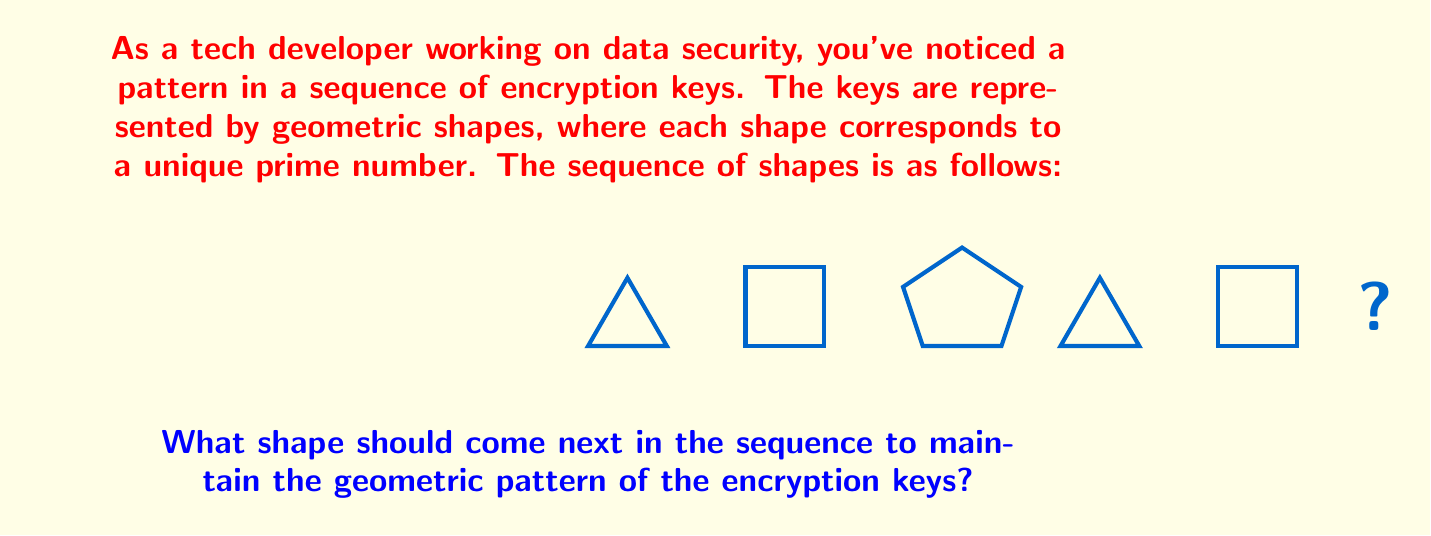Give your solution to this math problem. To solve this problem, let's follow these steps:

1) First, we need to identify the pattern in the sequence of shapes:
   Triangle, Square, Pentagon, Triangle, Square, ?

2) We can see that the pattern repeats after the pentagon:
   (Triangle, Square, Pentagon), (Triangle, Square, ?)

3) This suggests that the sequence is cyclic with a period of 3.

4) Given that each shape corresponds to a unique prime number, we can infer:
   Triangle = 2 (smallest prime)
   Square = 3 (next prime)
   Pentagon = 5 (next prime)

5) The pattern of primes would be:
   2, 3, 5, 2, 3, ?

6) Following this pattern, the next number in the sequence should be 5.

7) Since 5 corresponds to the pentagon in our established mapping, the next shape in the sequence should be a pentagon.

This pattern could be represented mathematically as:

$$S_n = \text{shape}((p_n \bmod 3) + 2)$$

Where $S_n$ is the nth shape in the sequence, $p_n$ is the nth prime number, and the function $\text{shape}(x)$ maps 2 to triangle, 3 to square, and 4 (or 1 due to modulo) to pentagon.
Answer: Pentagon 